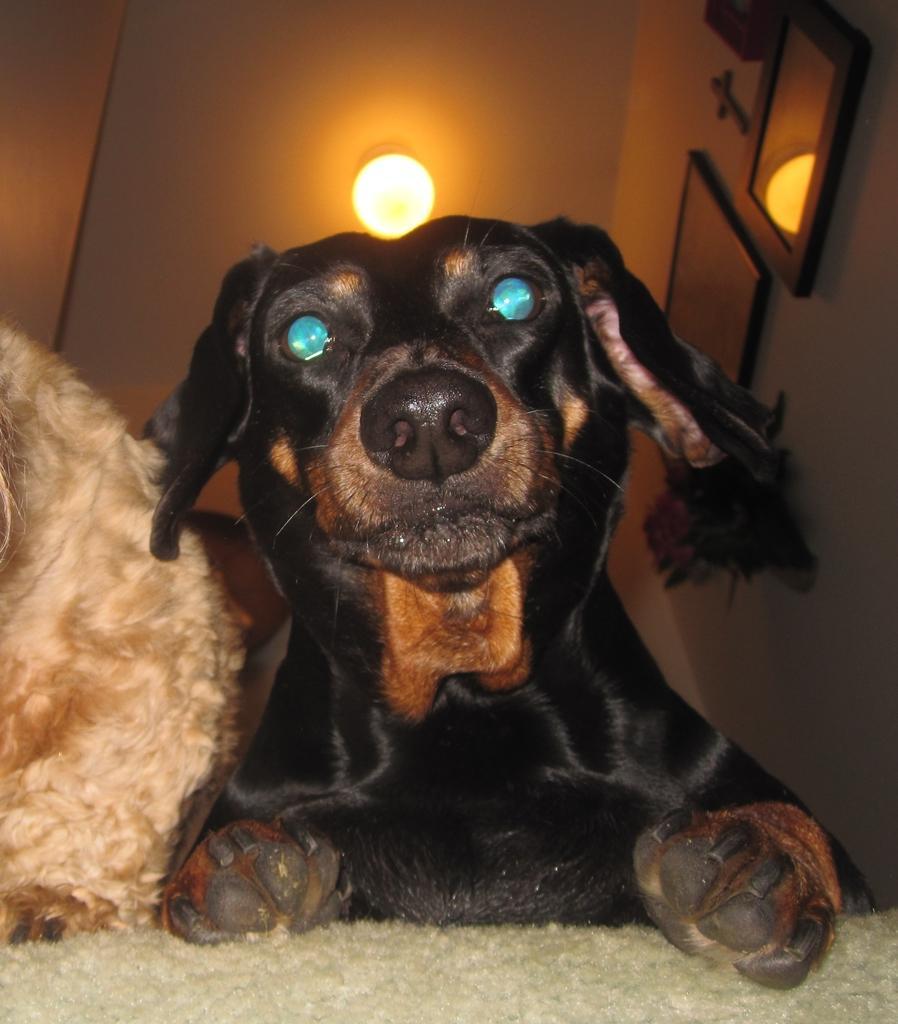Please provide a concise description of this image. In this image in the foreground there is one dog, beside the dog there is one animal. At the bottom there is towel, on the right side there are some photo frames on the wall. At the top there is one light and ceiling. 